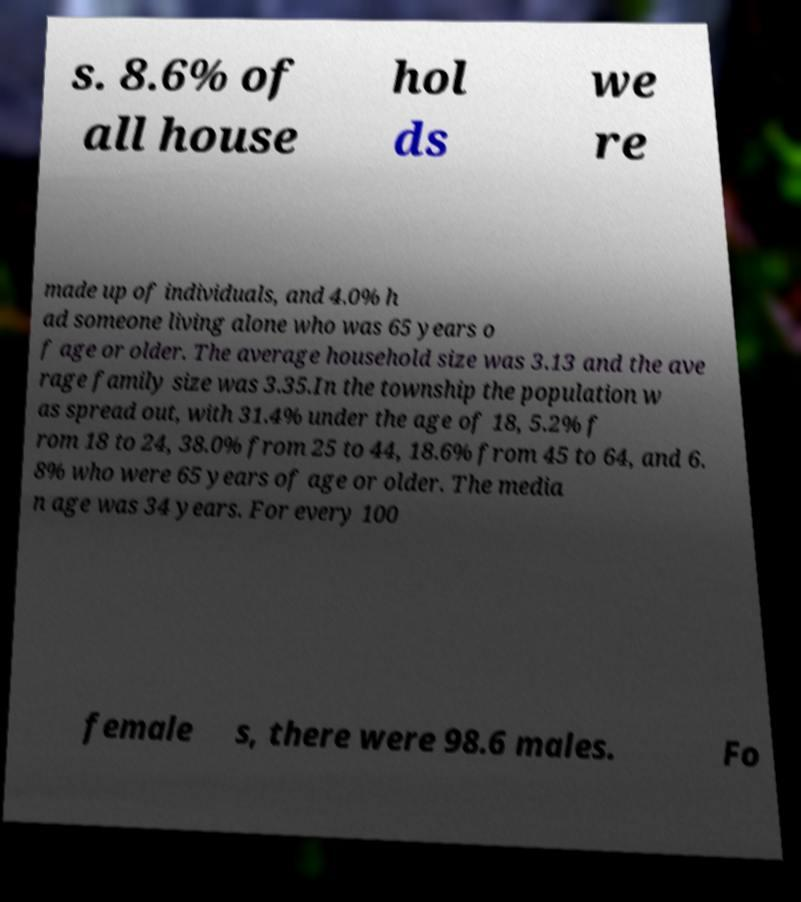I need the written content from this picture converted into text. Can you do that? s. 8.6% of all house hol ds we re made up of individuals, and 4.0% h ad someone living alone who was 65 years o f age or older. The average household size was 3.13 and the ave rage family size was 3.35.In the township the population w as spread out, with 31.4% under the age of 18, 5.2% f rom 18 to 24, 38.0% from 25 to 44, 18.6% from 45 to 64, and 6. 8% who were 65 years of age or older. The media n age was 34 years. For every 100 female s, there were 98.6 males. Fo 